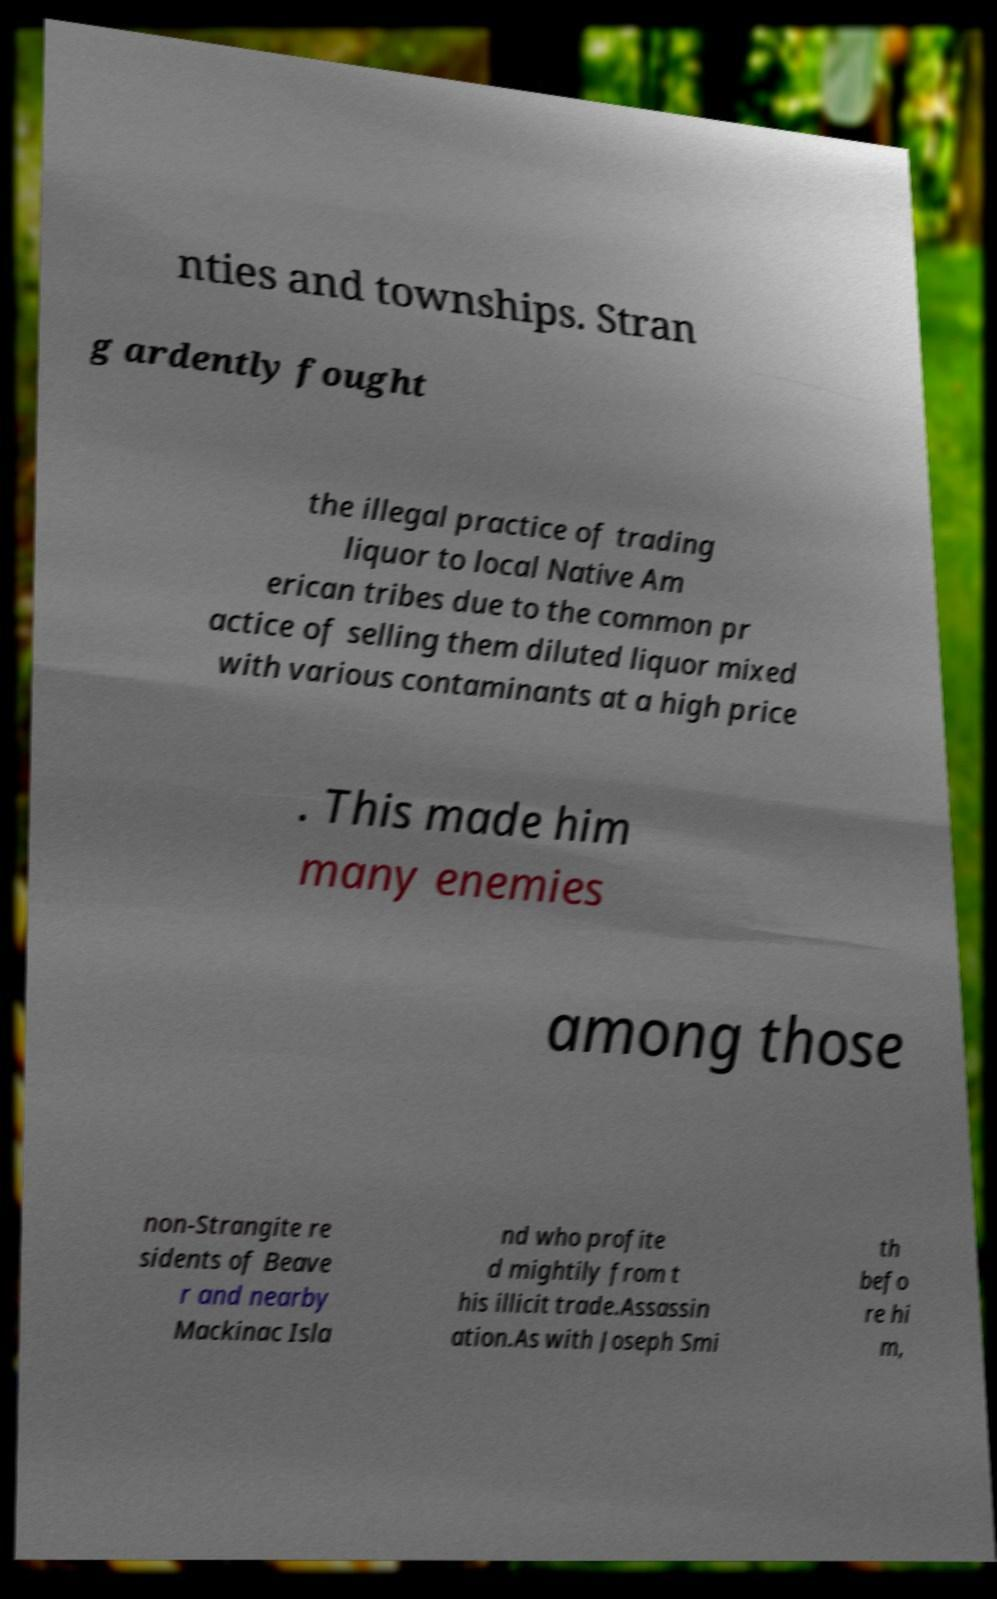Could you extract and type out the text from this image? nties and townships. Stran g ardently fought the illegal practice of trading liquor to local Native Am erican tribes due to the common pr actice of selling them diluted liquor mixed with various contaminants at a high price . This made him many enemies among those non-Strangite re sidents of Beave r and nearby Mackinac Isla nd who profite d mightily from t his illicit trade.Assassin ation.As with Joseph Smi th befo re hi m, 